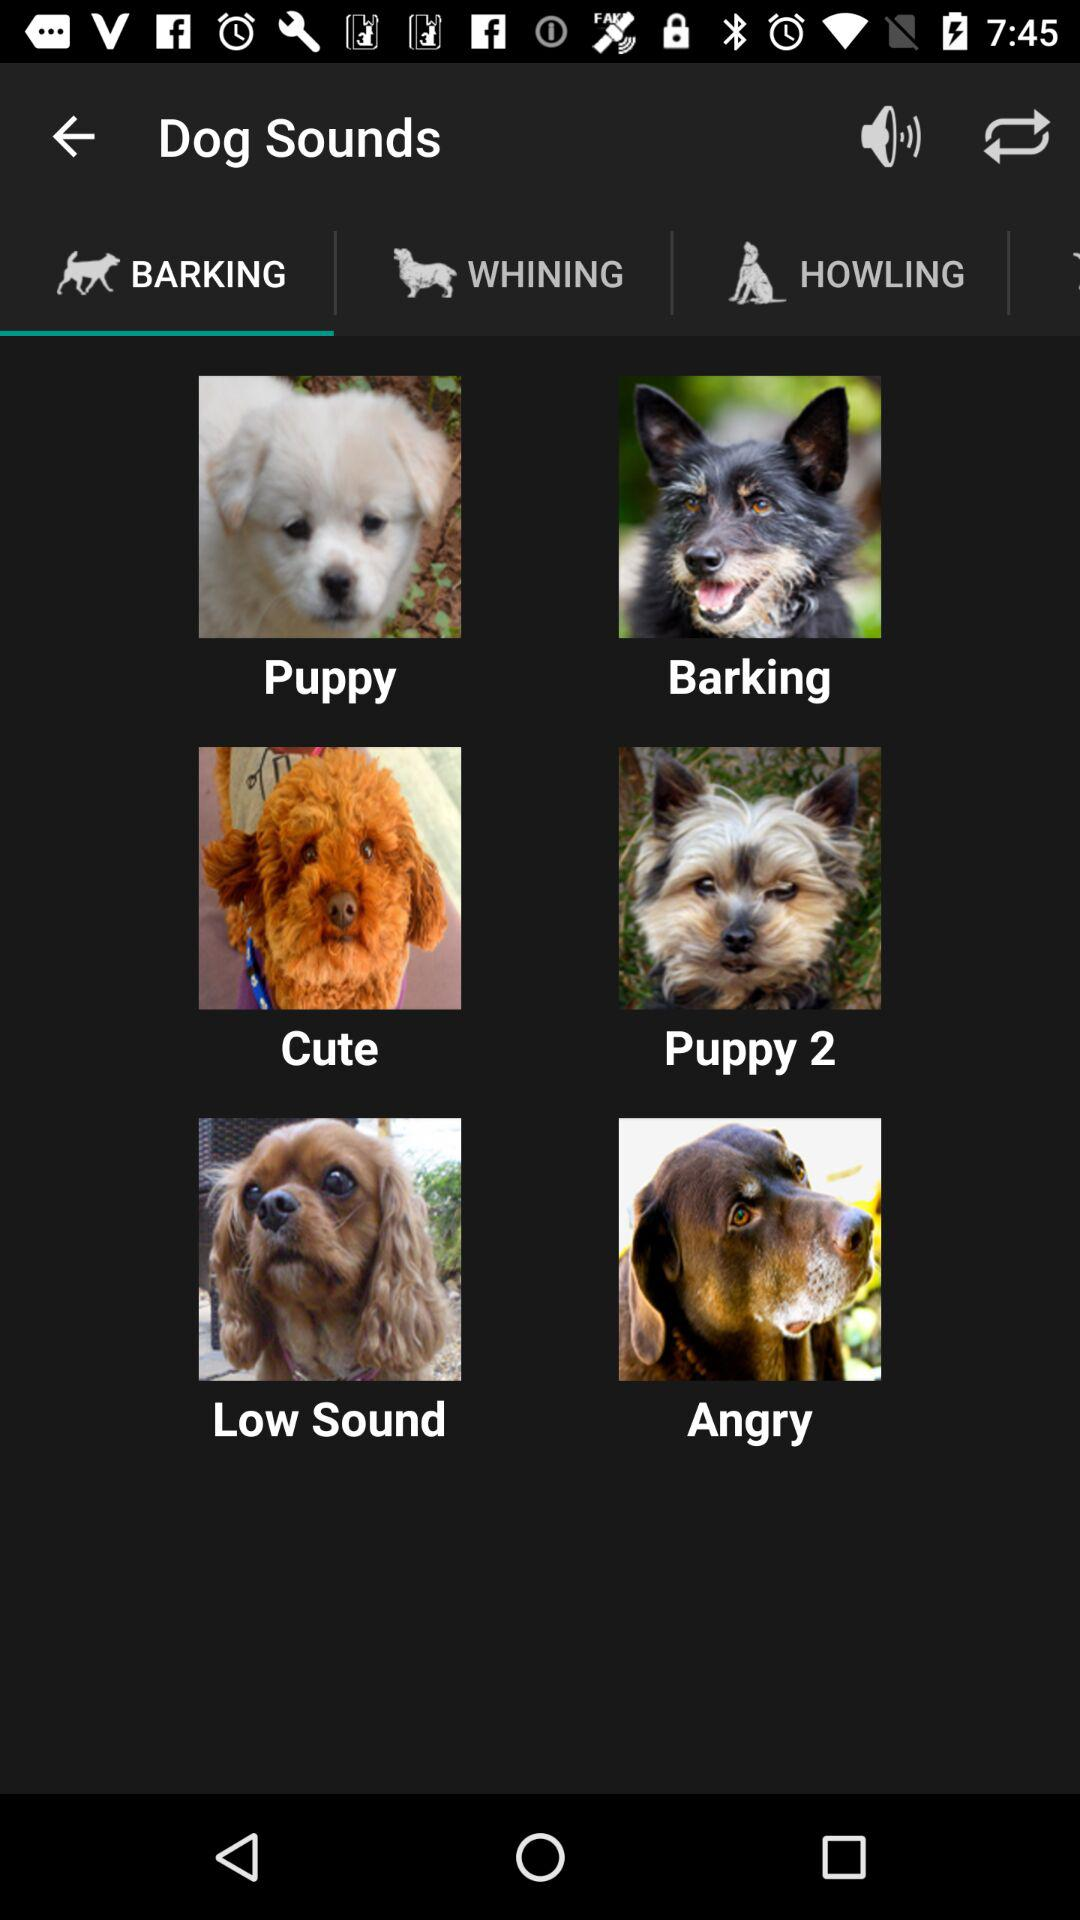Which option is selected in "Dog Sounds"? The selected option is "BARKING". 